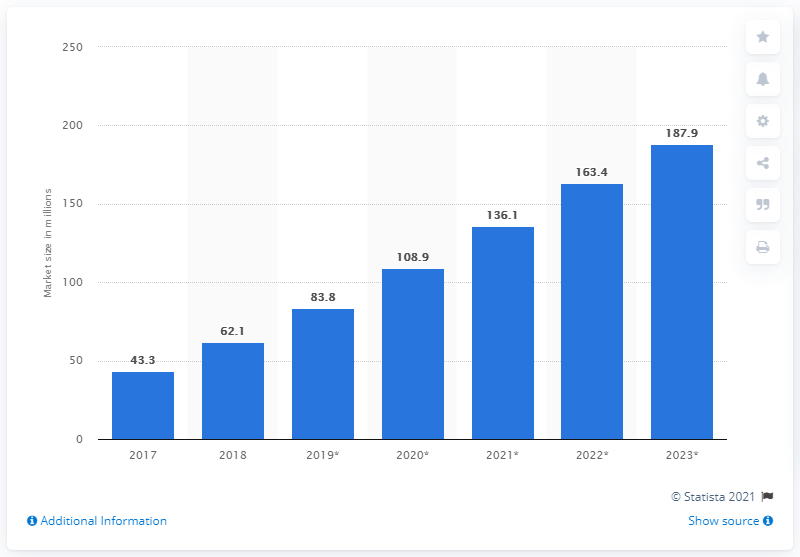Mention a couple of crucial points in this snapshot. Twitch is expected to have a market size of 187.9 by 2023. In 2017, Twitch's market size was 43.3 million viewers. 